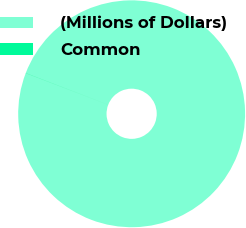Convert chart. <chart><loc_0><loc_0><loc_500><loc_500><pie_chart><fcel>(Millions of Dollars)<fcel>Common<nl><fcel>99.95%<fcel>0.05%<nl></chart> 